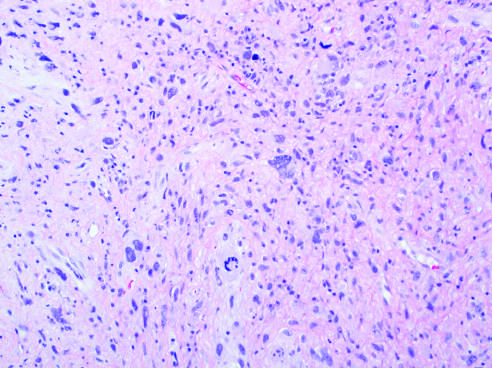what is spindled to polygonal cells?
Answer the question using a single word or phrase. Anaplastic 